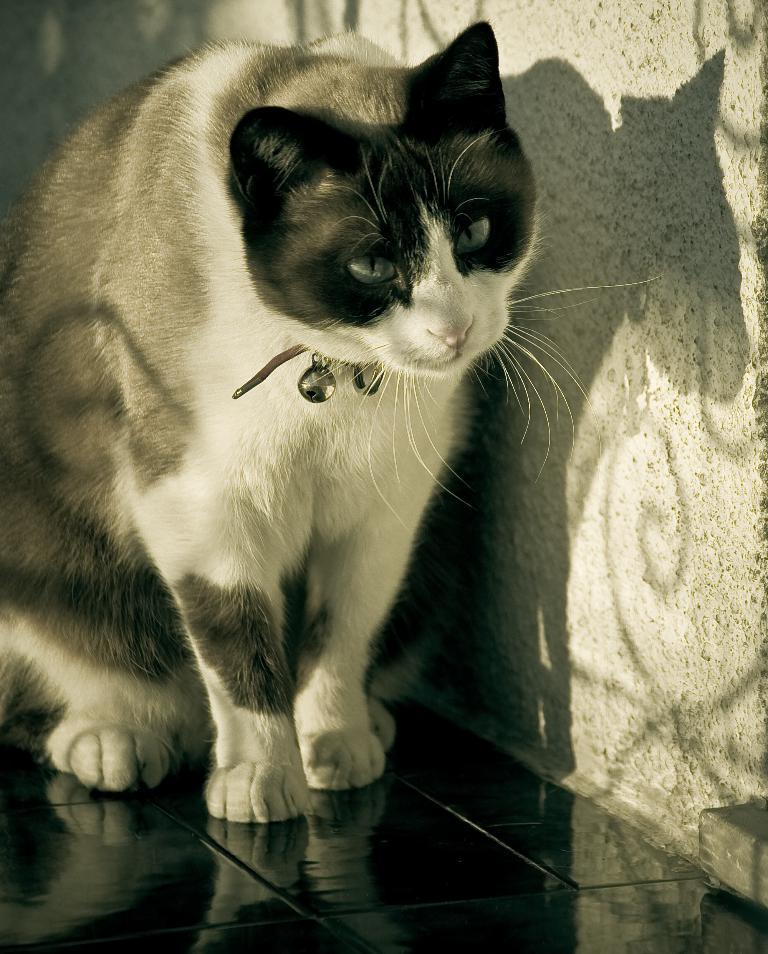What type of animal is in the picture? There is a cat in the picture. Can you describe the appearance of the cat? The cat is white and black in color. What else is present near the cat? There are beers near the cat. What can be seen in the background of the picture? There is a wall visible in the picture. How many passengers are visible in the picture? There are no passengers present in the picture; it features a cat and beers. What type of mint is growing near the cat? There is no mint present in the picture; it only features a cat, beers, and a wall. 